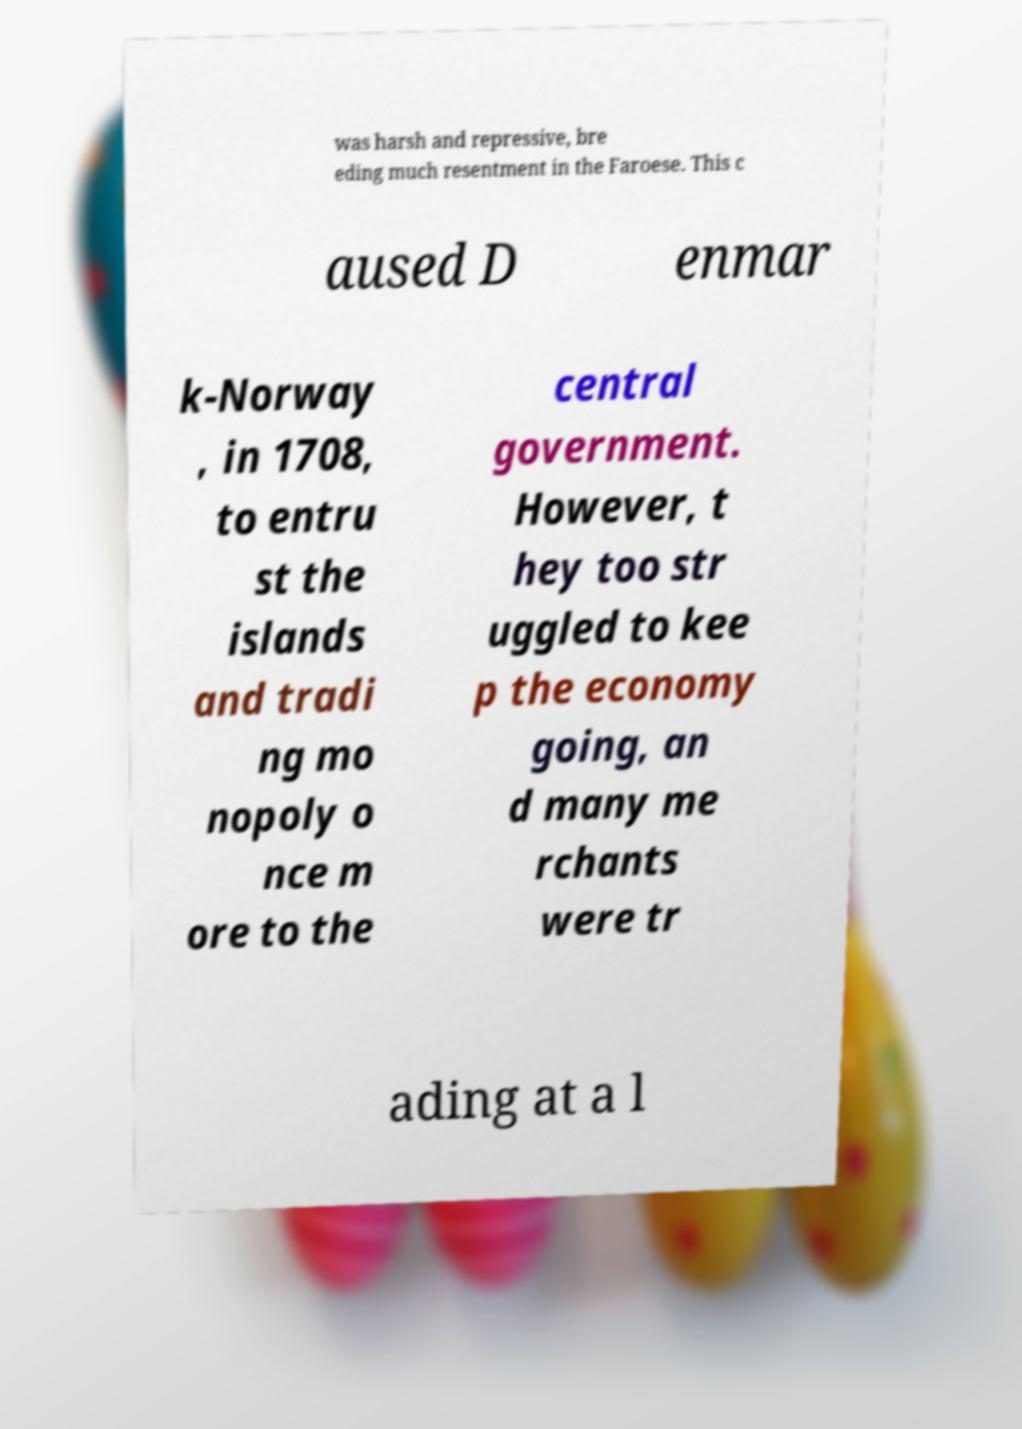For documentation purposes, I need the text within this image transcribed. Could you provide that? was harsh and repressive, bre eding much resentment in the Faroese. This c aused D enmar k-Norway , in 1708, to entru st the islands and tradi ng mo nopoly o nce m ore to the central government. However, t hey too str uggled to kee p the economy going, an d many me rchants were tr ading at a l 